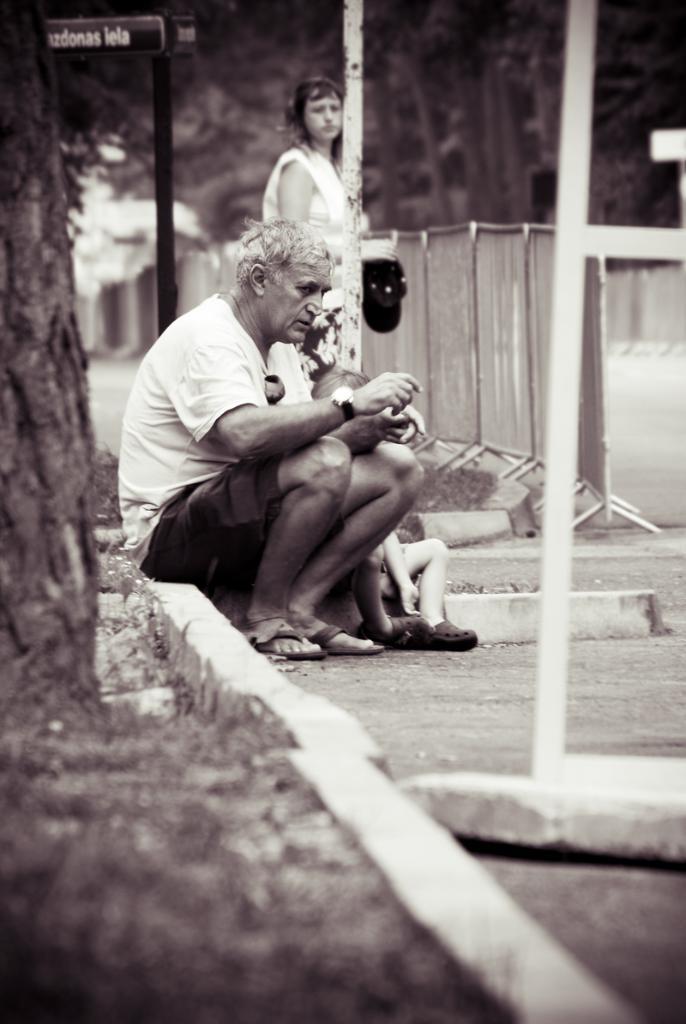In one or two sentences, can you explain what this image depicts? In this image I can see a person wearing white t shirt and short is sitting and a woman standing and few other persons sitting. I can see a tree, some grass, fed poles, the railing, the road, few trees and the sky in the background. 